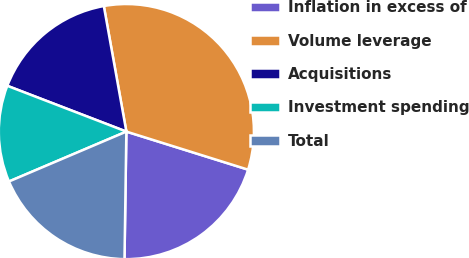Convert chart. <chart><loc_0><loc_0><loc_500><loc_500><pie_chart><fcel>Inflation in excess of<fcel>Volume leverage<fcel>Acquisitions<fcel>Investment spending<fcel>Total<nl><fcel>20.41%<fcel>32.65%<fcel>16.33%<fcel>12.24%<fcel>18.37%<nl></chart> 